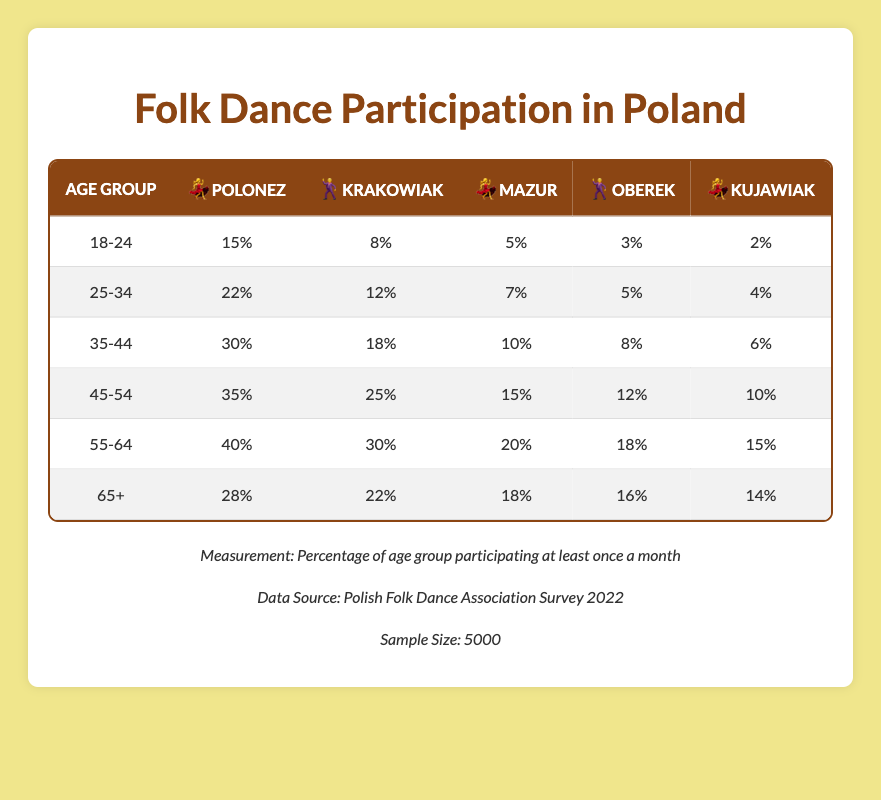What age group has the highest participation in Polonez? By looking at the table, we see the participation percentage for Polonez across age groups. The highest percentage is in the 55-64 age group, which is 40%.
Answer: 55-64 Which dance type has the lowest participation among the 18-24 age group? The table shows the participation percentages for each dance type within the 18-24 age group. The lowest percentage is for Kujawiak, which is 2%.
Answer: Kujawiak What is the total participation percentage for Krakowiak across all age groups? To find the total, we need to sum the participation percentages for Krakowiak: 8 + 12 + 18 + 25 + 30 + 22 = 115%.
Answer: 115% Is the participation in Mazur higher for the 25-34 age group than for the 65+ age group? The participation percentage for Mazur in the 25-34 age group is 7%, and for the 65+ age group, it is 18%. Since 7% is not higher than 18%, the answer is no.
Answer: No What percentage difference in Polonez participation is there between the 35-44 age group and the 55-64 age group? The participation in Polonez for the 35-44 age group is 30%, and for the 55-64 age group, it is 40%. The difference is 40 - 30 = 10%.
Answer: 10% Which age group dances the most in Oberek? The highest participation percentage for Oberek is found in the 45-54 age group, which has 12% participation.
Answer: 45-54 What is the average participation percentage for Kujawiak across all age groups? The percentages for Kujawiak are: 2, 4, 6, 10, 15, and 14. To calculate the average, sum these values: 2 + 4 + 6 + 10 + 15 + 14 = 51, and then divide by 6, which equals 8.5%.
Answer: 8.5% Is it true that more than 50% of the 45-54 age group participates in any folk dance? The combined participation for any dance type in the 45-54 age group is 35 + 25 + 15 + 12 + 10 = 107%. Since 107 is greater than 50, the statement is true.
Answer: Yes What is the participation percentage for Mazur in the 55-64 age group? The participation for Mazur in the 55-64 age group is directly given as 20%.
Answer: 20% 